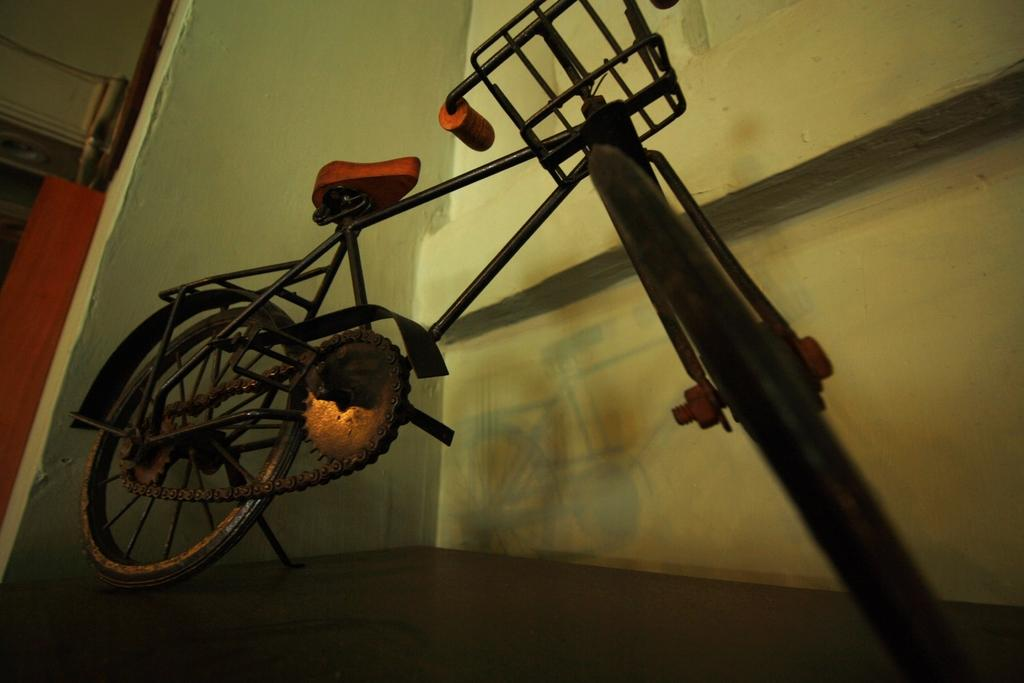What is the color of the bicycle in the image? There is a black color bicycle in the image. What is located behind the bicycle in the image? There is a wall visible behind the bicycle in the image. What type of oil can be seen dripping from the bicycle in the image? There is no oil visible dripping from the bicycle in the image. Can you tell me how many owls are perched on the bicycle in the image? There are no owls present on the bicycle in the image. 